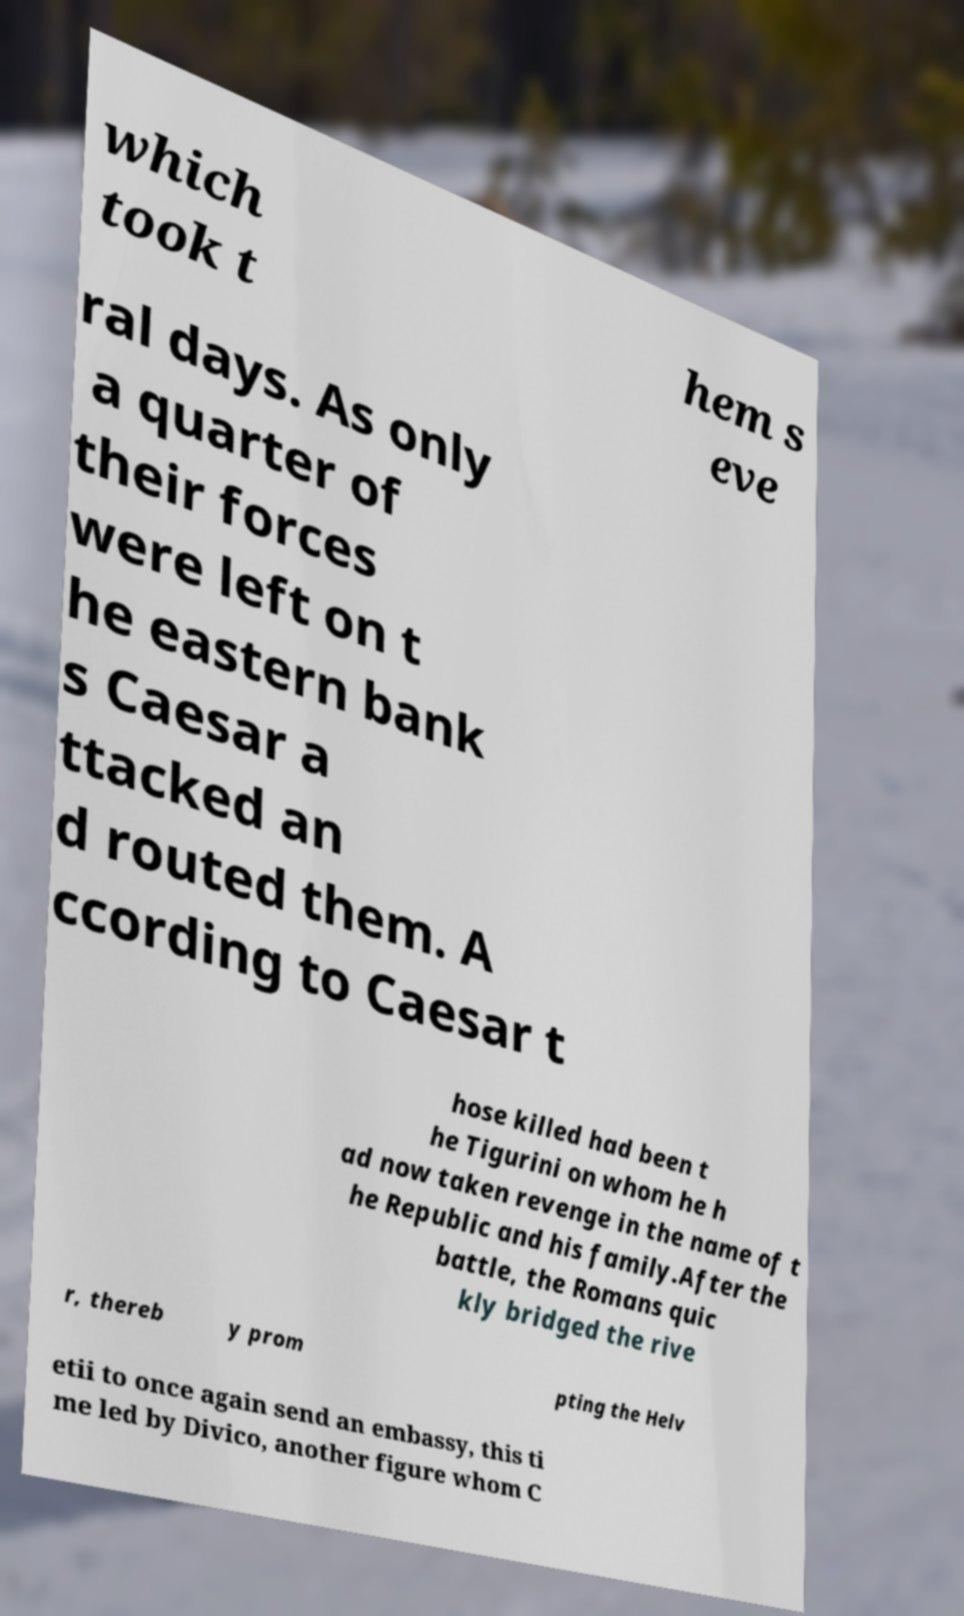Please identify and transcribe the text found in this image. which took t hem s eve ral days. As only a quarter of their forces were left on t he eastern bank s Caesar a ttacked an d routed them. A ccording to Caesar t hose killed had been t he Tigurini on whom he h ad now taken revenge in the name of t he Republic and his family.After the battle, the Romans quic kly bridged the rive r, thereb y prom pting the Helv etii to once again send an embassy, this ti me led by Divico, another figure whom C 